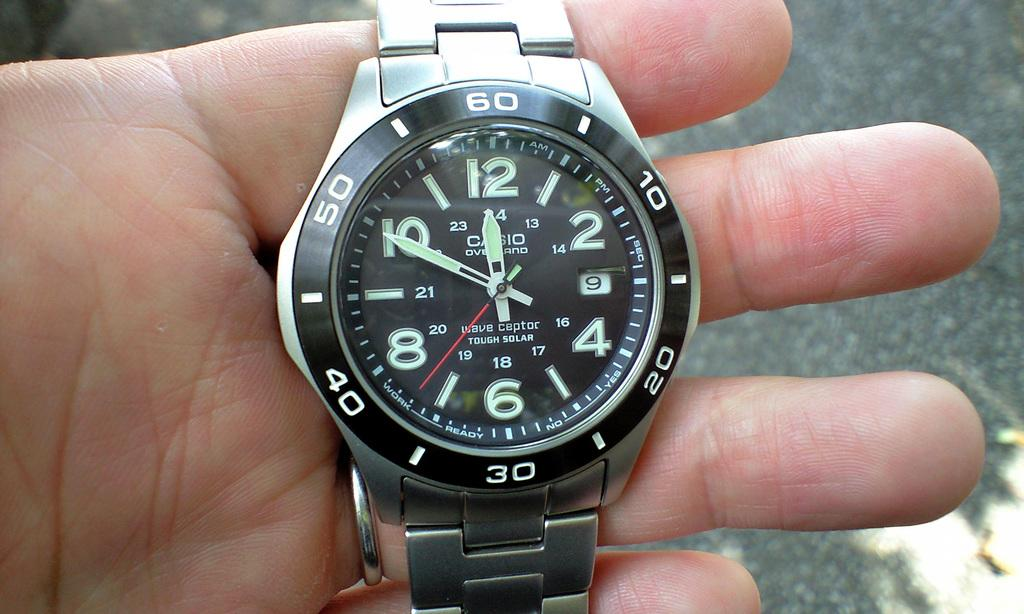<image>
Summarize the visual content of the image. Person holding a wristwatch which says "CASIO" on it. 